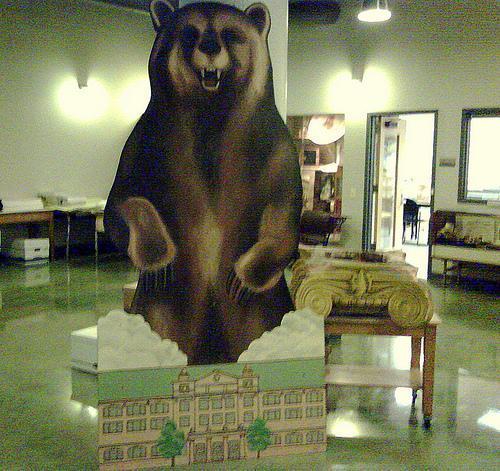How many bears are there?
Give a very brief answer. 1. 